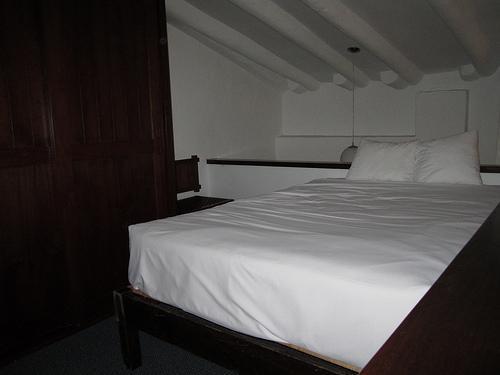How many beds are there?
Give a very brief answer. 1. 